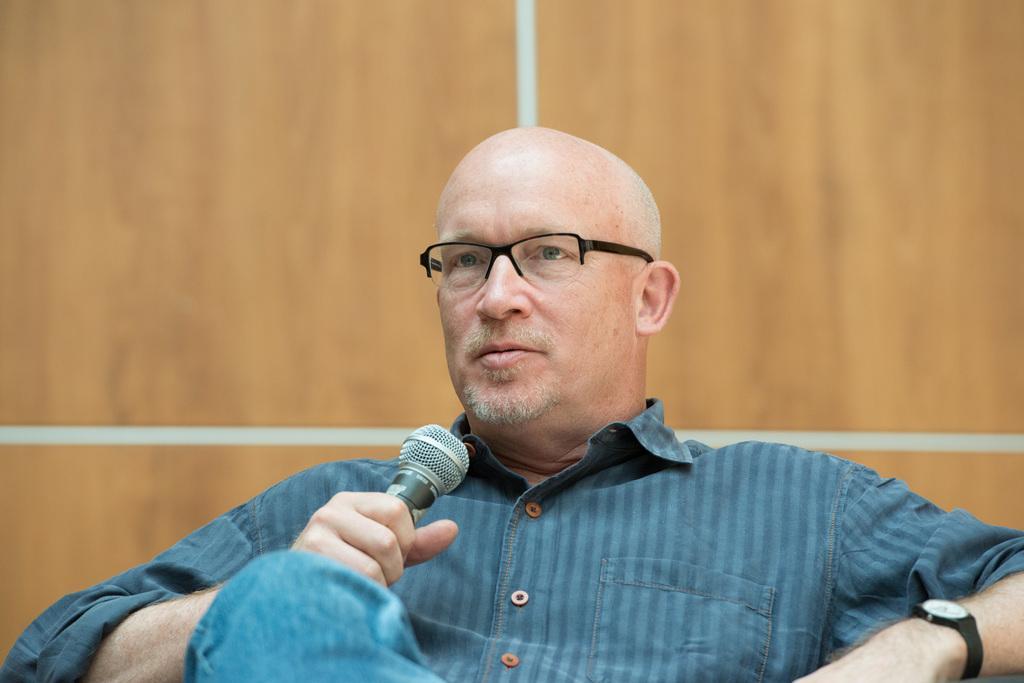Describe this image in one or two sentences. This image consists of a man wearing a blue shirt and a blue jeans. He is holding a mic. In the background, there is a wall in brown color. 